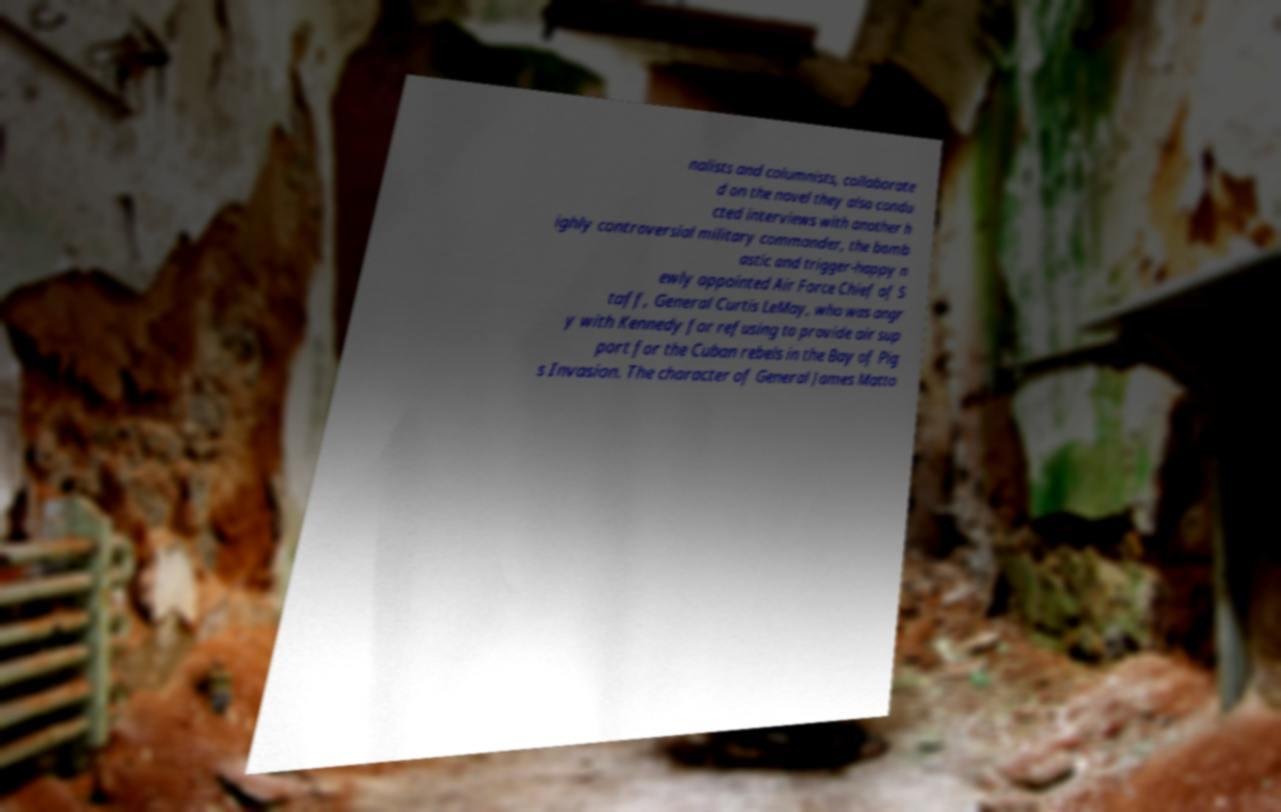Please read and relay the text visible in this image. What does it say? nalists and columnists, collaborate d on the novel they also condu cted interviews with another h ighly controversial military commander, the bomb astic and trigger-happy n ewly appointed Air Force Chief of S taff, General Curtis LeMay, who was angr y with Kennedy for refusing to provide air sup port for the Cuban rebels in the Bay of Pig s Invasion. The character of General James Matto 